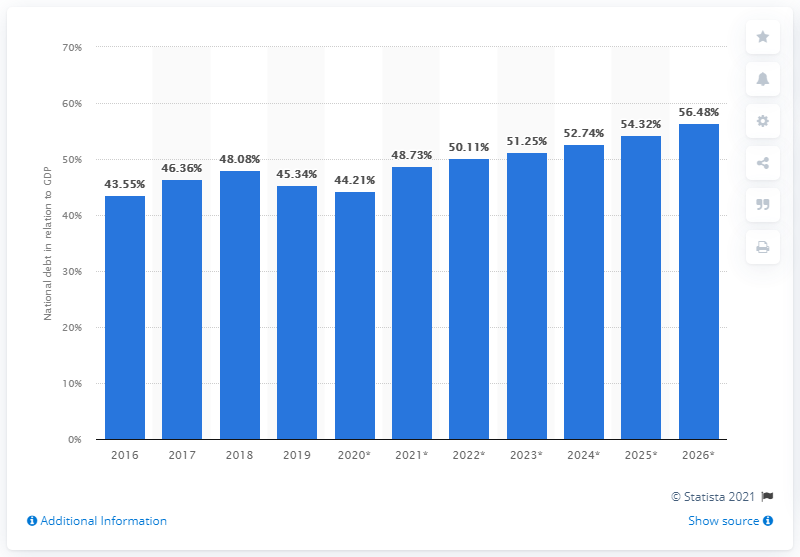Point out several critical features in this image. In 2019, the national debt of Vanuatu was 45.34. 